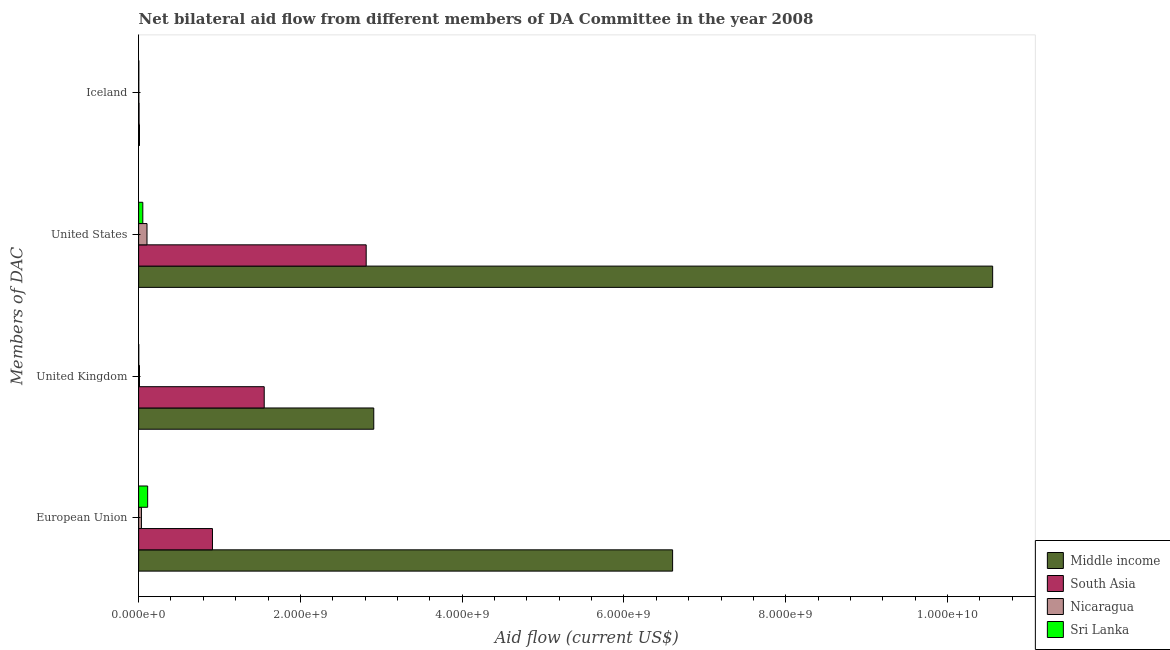Are the number of bars on each tick of the Y-axis equal?
Your answer should be very brief. Yes. What is the amount of aid given by iceland in South Asia?
Offer a very short reply. 5.30e+06. Across all countries, what is the maximum amount of aid given by eu?
Offer a terse response. 6.60e+09. Across all countries, what is the minimum amount of aid given by eu?
Provide a short and direct response. 3.48e+07. In which country was the amount of aid given by eu minimum?
Your answer should be very brief. Nicaragua. What is the total amount of aid given by iceland in the graph?
Your answer should be very brief. 2.06e+07. What is the difference between the amount of aid given by iceland in South Asia and that in Nicaragua?
Your answer should be very brief. 3.07e+06. What is the difference between the amount of aid given by uk in Middle income and the amount of aid given by eu in Sri Lanka?
Provide a short and direct response. 2.80e+09. What is the average amount of aid given by us per country?
Your response must be concise. 3.38e+09. What is the difference between the amount of aid given by iceland and amount of aid given by uk in Nicaragua?
Your answer should be compact. -8.43e+06. What is the ratio of the amount of aid given by iceland in South Asia to that in Middle income?
Your answer should be compact. 0.5. Is the amount of aid given by us in South Asia less than that in Nicaragua?
Keep it short and to the point. No. Is the difference between the amount of aid given by eu in South Asia and Middle income greater than the difference between the amount of aid given by iceland in South Asia and Middle income?
Give a very brief answer. No. What is the difference between the highest and the second highest amount of aid given by eu?
Offer a terse response. 5.69e+09. What is the difference between the highest and the lowest amount of aid given by eu?
Ensure brevity in your answer.  6.57e+09. In how many countries, is the amount of aid given by us greater than the average amount of aid given by us taken over all countries?
Offer a very short reply. 1. Is it the case that in every country, the sum of the amount of aid given by eu and amount of aid given by iceland is greater than the sum of amount of aid given by uk and amount of aid given by us?
Offer a terse response. Yes. What does the 4th bar from the top in Iceland represents?
Your answer should be compact. Middle income. What does the 3rd bar from the bottom in United Kingdom represents?
Keep it short and to the point. Nicaragua. Are all the bars in the graph horizontal?
Offer a terse response. Yes. What is the difference between two consecutive major ticks on the X-axis?
Ensure brevity in your answer.  2.00e+09. Does the graph contain any zero values?
Provide a succinct answer. No. How are the legend labels stacked?
Give a very brief answer. Vertical. What is the title of the graph?
Provide a succinct answer. Net bilateral aid flow from different members of DA Committee in the year 2008. What is the label or title of the Y-axis?
Your answer should be very brief. Members of DAC. What is the Aid flow (current US$) in Middle income in European Union?
Give a very brief answer. 6.60e+09. What is the Aid flow (current US$) of South Asia in European Union?
Provide a succinct answer. 9.13e+08. What is the Aid flow (current US$) of Nicaragua in European Union?
Your answer should be very brief. 3.48e+07. What is the Aid flow (current US$) of Sri Lanka in European Union?
Keep it short and to the point. 1.12e+08. What is the Aid flow (current US$) in Middle income in United Kingdom?
Offer a very short reply. 2.91e+09. What is the Aid flow (current US$) of South Asia in United Kingdom?
Give a very brief answer. 1.55e+09. What is the Aid flow (current US$) in Nicaragua in United Kingdom?
Your answer should be compact. 1.07e+07. What is the Aid flow (current US$) of Sri Lanka in United Kingdom?
Your response must be concise. 1.75e+06. What is the Aid flow (current US$) in Middle income in United States?
Offer a terse response. 1.06e+1. What is the Aid flow (current US$) of South Asia in United States?
Provide a succinct answer. 2.81e+09. What is the Aid flow (current US$) in Nicaragua in United States?
Your response must be concise. 1.04e+08. What is the Aid flow (current US$) of Sri Lanka in United States?
Your response must be concise. 5.18e+07. What is the Aid flow (current US$) in Middle income in Iceland?
Ensure brevity in your answer.  1.06e+07. What is the Aid flow (current US$) of South Asia in Iceland?
Your response must be concise. 5.30e+06. What is the Aid flow (current US$) of Nicaragua in Iceland?
Provide a succinct answer. 2.23e+06. What is the Aid flow (current US$) in Sri Lanka in Iceland?
Your answer should be very brief. 2.39e+06. Across all Members of DAC, what is the maximum Aid flow (current US$) in Middle income?
Ensure brevity in your answer.  1.06e+1. Across all Members of DAC, what is the maximum Aid flow (current US$) in South Asia?
Make the answer very short. 2.81e+09. Across all Members of DAC, what is the maximum Aid flow (current US$) of Nicaragua?
Offer a terse response. 1.04e+08. Across all Members of DAC, what is the maximum Aid flow (current US$) in Sri Lanka?
Offer a very short reply. 1.12e+08. Across all Members of DAC, what is the minimum Aid flow (current US$) of Middle income?
Keep it short and to the point. 1.06e+07. Across all Members of DAC, what is the minimum Aid flow (current US$) of South Asia?
Your answer should be compact. 5.30e+06. Across all Members of DAC, what is the minimum Aid flow (current US$) of Nicaragua?
Keep it short and to the point. 2.23e+06. Across all Members of DAC, what is the minimum Aid flow (current US$) in Sri Lanka?
Give a very brief answer. 1.75e+06. What is the total Aid flow (current US$) of Middle income in the graph?
Give a very brief answer. 2.01e+1. What is the total Aid flow (current US$) in South Asia in the graph?
Your answer should be very brief. 5.28e+09. What is the total Aid flow (current US$) in Nicaragua in the graph?
Provide a short and direct response. 1.51e+08. What is the total Aid flow (current US$) of Sri Lanka in the graph?
Ensure brevity in your answer.  1.68e+08. What is the difference between the Aid flow (current US$) of Middle income in European Union and that in United Kingdom?
Ensure brevity in your answer.  3.69e+09. What is the difference between the Aid flow (current US$) in South Asia in European Union and that in United Kingdom?
Keep it short and to the point. -6.40e+08. What is the difference between the Aid flow (current US$) in Nicaragua in European Union and that in United Kingdom?
Make the answer very short. 2.41e+07. What is the difference between the Aid flow (current US$) in Sri Lanka in European Union and that in United Kingdom?
Offer a very short reply. 1.10e+08. What is the difference between the Aid flow (current US$) in Middle income in European Union and that in United States?
Provide a short and direct response. -3.96e+09. What is the difference between the Aid flow (current US$) of South Asia in European Union and that in United States?
Your answer should be very brief. -1.90e+09. What is the difference between the Aid flow (current US$) of Nicaragua in European Union and that in United States?
Your response must be concise. -6.87e+07. What is the difference between the Aid flow (current US$) in Sri Lanka in European Union and that in United States?
Offer a very short reply. 5.98e+07. What is the difference between the Aid flow (current US$) in Middle income in European Union and that in Iceland?
Ensure brevity in your answer.  6.59e+09. What is the difference between the Aid flow (current US$) of South Asia in European Union and that in Iceland?
Your answer should be very brief. 9.08e+08. What is the difference between the Aid flow (current US$) of Nicaragua in European Union and that in Iceland?
Ensure brevity in your answer.  3.26e+07. What is the difference between the Aid flow (current US$) of Sri Lanka in European Union and that in Iceland?
Ensure brevity in your answer.  1.09e+08. What is the difference between the Aid flow (current US$) in Middle income in United Kingdom and that in United States?
Your answer should be compact. -7.65e+09. What is the difference between the Aid flow (current US$) in South Asia in United Kingdom and that in United States?
Offer a very short reply. -1.26e+09. What is the difference between the Aid flow (current US$) of Nicaragua in United Kingdom and that in United States?
Ensure brevity in your answer.  -9.29e+07. What is the difference between the Aid flow (current US$) of Sri Lanka in United Kingdom and that in United States?
Your answer should be very brief. -5.00e+07. What is the difference between the Aid flow (current US$) in Middle income in United Kingdom and that in Iceland?
Offer a very short reply. 2.90e+09. What is the difference between the Aid flow (current US$) of South Asia in United Kingdom and that in Iceland?
Ensure brevity in your answer.  1.55e+09. What is the difference between the Aid flow (current US$) in Nicaragua in United Kingdom and that in Iceland?
Provide a succinct answer. 8.43e+06. What is the difference between the Aid flow (current US$) of Sri Lanka in United Kingdom and that in Iceland?
Your answer should be compact. -6.40e+05. What is the difference between the Aid flow (current US$) in Middle income in United States and that in Iceland?
Your answer should be very brief. 1.05e+1. What is the difference between the Aid flow (current US$) in South Asia in United States and that in Iceland?
Make the answer very short. 2.81e+09. What is the difference between the Aid flow (current US$) in Nicaragua in United States and that in Iceland?
Offer a very short reply. 1.01e+08. What is the difference between the Aid flow (current US$) of Sri Lanka in United States and that in Iceland?
Your answer should be very brief. 4.94e+07. What is the difference between the Aid flow (current US$) of Middle income in European Union and the Aid flow (current US$) of South Asia in United Kingdom?
Provide a succinct answer. 5.05e+09. What is the difference between the Aid flow (current US$) of Middle income in European Union and the Aid flow (current US$) of Nicaragua in United Kingdom?
Your answer should be compact. 6.59e+09. What is the difference between the Aid flow (current US$) of Middle income in European Union and the Aid flow (current US$) of Sri Lanka in United Kingdom?
Your response must be concise. 6.60e+09. What is the difference between the Aid flow (current US$) in South Asia in European Union and the Aid flow (current US$) in Nicaragua in United Kingdom?
Provide a short and direct response. 9.02e+08. What is the difference between the Aid flow (current US$) of South Asia in European Union and the Aid flow (current US$) of Sri Lanka in United Kingdom?
Keep it short and to the point. 9.11e+08. What is the difference between the Aid flow (current US$) in Nicaragua in European Union and the Aid flow (current US$) in Sri Lanka in United Kingdom?
Your answer should be very brief. 3.30e+07. What is the difference between the Aid flow (current US$) in Middle income in European Union and the Aid flow (current US$) in South Asia in United States?
Provide a short and direct response. 3.79e+09. What is the difference between the Aid flow (current US$) of Middle income in European Union and the Aid flow (current US$) of Nicaragua in United States?
Your answer should be compact. 6.50e+09. What is the difference between the Aid flow (current US$) in Middle income in European Union and the Aid flow (current US$) in Sri Lanka in United States?
Provide a succinct answer. 6.55e+09. What is the difference between the Aid flow (current US$) of South Asia in European Union and the Aid flow (current US$) of Nicaragua in United States?
Offer a very short reply. 8.09e+08. What is the difference between the Aid flow (current US$) in South Asia in European Union and the Aid flow (current US$) in Sri Lanka in United States?
Offer a very short reply. 8.61e+08. What is the difference between the Aid flow (current US$) in Nicaragua in European Union and the Aid flow (current US$) in Sri Lanka in United States?
Keep it short and to the point. -1.70e+07. What is the difference between the Aid flow (current US$) in Middle income in European Union and the Aid flow (current US$) in South Asia in Iceland?
Offer a very short reply. 6.60e+09. What is the difference between the Aid flow (current US$) of Middle income in European Union and the Aid flow (current US$) of Nicaragua in Iceland?
Provide a succinct answer. 6.60e+09. What is the difference between the Aid flow (current US$) of Middle income in European Union and the Aid flow (current US$) of Sri Lanka in Iceland?
Provide a succinct answer. 6.60e+09. What is the difference between the Aid flow (current US$) of South Asia in European Union and the Aid flow (current US$) of Nicaragua in Iceland?
Provide a succinct answer. 9.11e+08. What is the difference between the Aid flow (current US$) of South Asia in European Union and the Aid flow (current US$) of Sri Lanka in Iceland?
Make the answer very short. 9.10e+08. What is the difference between the Aid flow (current US$) in Nicaragua in European Union and the Aid flow (current US$) in Sri Lanka in Iceland?
Ensure brevity in your answer.  3.24e+07. What is the difference between the Aid flow (current US$) in Middle income in United Kingdom and the Aid flow (current US$) in South Asia in United States?
Ensure brevity in your answer.  9.37e+07. What is the difference between the Aid flow (current US$) in Middle income in United Kingdom and the Aid flow (current US$) in Nicaragua in United States?
Your answer should be very brief. 2.80e+09. What is the difference between the Aid flow (current US$) of Middle income in United Kingdom and the Aid flow (current US$) of Sri Lanka in United States?
Ensure brevity in your answer.  2.86e+09. What is the difference between the Aid flow (current US$) of South Asia in United Kingdom and the Aid flow (current US$) of Nicaragua in United States?
Keep it short and to the point. 1.45e+09. What is the difference between the Aid flow (current US$) in South Asia in United Kingdom and the Aid flow (current US$) in Sri Lanka in United States?
Provide a short and direct response. 1.50e+09. What is the difference between the Aid flow (current US$) of Nicaragua in United Kingdom and the Aid flow (current US$) of Sri Lanka in United States?
Your answer should be compact. -4.11e+07. What is the difference between the Aid flow (current US$) in Middle income in United Kingdom and the Aid flow (current US$) in South Asia in Iceland?
Keep it short and to the point. 2.90e+09. What is the difference between the Aid flow (current US$) of Middle income in United Kingdom and the Aid flow (current US$) of Nicaragua in Iceland?
Offer a terse response. 2.90e+09. What is the difference between the Aid flow (current US$) of Middle income in United Kingdom and the Aid flow (current US$) of Sri Lanka in Iceland?
Make the answer very short. 2.90e+09. What is the difference between the Aid flow (current US$) in South Asia in United Kingdom and the Aid flow (current US$) in Nicaragua in Iceland?
Ensure brevity in your answer.  1.55e+09. What is the difference between the Aid flow (current US$) of South Asia in United Kingdom and the Aid flow (current US$) of Sri Lanka in Iceland?
Give a very brief answer. 1.55e+09. What is the difference between the Aid flow (current US$) in Nicaragua in United Kingdom and the Aid flow (current US$) in Sri Lanka in Iceland?
Make the answer very short. 8.27e+06. What is the difference between the Aid flow (current US$) in Middle income in United States and the Aid flow (current US$) in South Asia in Iceland?
Offer a very short reply. 1.06e+1. What is the difference between the Aid flow (current US$) in Middle income in United States and the Aid flow (current US$) in Nicaragua in Iceland?
Your answer should be compact. 1.06e+1. What is the difference between the Aid flow (current US$) of Middle income in United States and the Aid flow (current US$) of Sri Lanka in Iceland?
Offer a very short reply. 1.06e+1. What is the difference between the Aid flow (current US$) in South Asia in United States and the Aid flow (current US$) in Nicaragua in Iceland?
Give a very brief answer. 2.81e+09. What is the difference between the Aid flow (current US$) of South Asia in United States and the Aid flow (current US$) of Sri Lanka in Iceland?
Offer a very short reply. 2.81e+09. What is the difference between the Aid flow (current US$) of Nicaragua in United States and the Aid flow (current US$) of Sri Lanka in Iceland?
Your answer should be very brief. 1.01e+08. What is the average Aid flow (current US$) of Middle income per Members of DAC?
Your response must be concise. 5.02e+09. What is the average Aid flow (current US$) in South Asia per Members of DAC?
Provide a succinct answer. 1.32e+09. What is the average Aid flow (current US$) in Nicaragua per Members of DAC?
Offer a very short reply. 3.78e+07. What is the average Aid flow (current US$) in Sri Lanka per Members of DAC?
Your response must be concise. 4.19e+07. What is the difference between the Aid flow (current US$) of Middle income and Aid flow (current US$) of South Asia in European Union?
Offer a very short reply. 5.69e+09. What is the difference between the Aid flow (current US$) of Middle income and Aid flow (current US$) of Nicaragua in European Union?
Your answer should be very brief. 6.57e+09. What is the difference between the Aid flow (current US$) of Middle income and Aid flow (current US$) of Sri Lanka in European Union?
Keep it short and to the point. 6.49e+09. What is the difference between the Aid flow (current US$) in South Asia and Aid flow (current US$) in Nicaragua in European Union?
Offer a terse response. 8.78e+08. What is the difference between the Aid flow (current US$) of South Asia and Aid flow (current US$) of Sri Lanka in European Union?
Your response must be concise. 8.01e+08. What is the difference between the Aid flow (current US$) in Nicaragua and Aid flow (current US$) in Sri Lanka in European Union?
Keep it short and to the point. -7.68e+07. What is the difference between the Aid flow (current US$) of Middle income and Aid flow (current US$) of South Asia in United Kingdom?
Offer a terse response. 1.35e+09. What is the difference between the Aid flow (current US$) of Middle income and Aid flow (current US$) of Nicaragua in United Kingdom?
Offer a terse response. 2.90e+09. What is the difference between the Aid flow (current US$) in Middle income and Aid flow (current US$) in Sri Lanka in United Kingdom?
Offer a terse response. 2.91e+09. What is the difference between the Aid flow (current US$) of South Asia and Aid flow (current US$) of Nicaragua in United Kingdom?
Your answer should be compact. 1.54e+09. What is the difference between the Aid flow (current US$) in South Asia and Aid flow (current US$) in Sri Lanka in United Kingdom?
Give a very brief answer. 1.55e+09. What is the difference between the Aid flow (current US$) in Nicaragua and Aid flow (current US$) in Sri Lanka in United Kingdom?
Your answer should be very brief. 8.91e+06. What is the difference between the Aid flow (current US$) in Middle income and Aid flow (current US$) in South Asia in United States?
Offer a very short reply. 7.74e+09. What is the difference between the Aid flow (current US$) of Middle income and Aid flow (current US$) of Nicaragua in United States?
Make the answer very short. 1.05e+1. What is the difference between the Aid flow (current US$) in Middle income and Aid flow (current US$) in Sri Lanka in United States?
Give a very brief answer. 1.05e+1. What is the difference between the Aid flow (current US$) of South Asia and Aid flow (current US$) of Nicaragua in United States?
Offer a very short reply. 2.71e+09. What is the difference between the Aid flow (current US$) in South Asia and Aid flow (current US$) in Sri Lanka in United States?
Ensure brevity in your answer.  2.76e+09. What is the difference between the Aid flow (current US$) of Nicaragua and Aid flow (current US$) of Sri Lanka in United States?
Your response must be concise. 5.17e+07. What is the difference between the Aid flow (current US$) of Middle income and Aid flow (current US$) of South Asia in Iceland?
Your answer should be very brief. 5.33e+06. What is the difference between the Aid flow (current US$) in Middle income and Aid flow (current US$) in Nicaragua in Iceland?
Make the answer very short. 8.40e+06. What is the difference between the Aid flow (current US$) in Middle income and Aid flow (current US$) in Sri Lanka in Iceland?
Provide a succinct answer. 8.24e+06. What is the difference between the Aid flow (current US$) of South Asia and Aid flow (current US$) of Nicaragua in Iceland?
Give a very brief answer. 3.07e+06. What is the difference between the Aid flow (current US$) in South Asia and Aid flow (current US$) in Sri Lanka in Iceland?
Provide a succinct answer. 2.91e+06. What is the difference between the Aid flow (current US$) of Nicaragua and Aid flow (current US$) of Sri Lanka in Iceland?
Provide a short and direct response. -1.60e+05. What is the ratio of the Aid flow (current US$) of Middle income in European Union to that in United Kingdom?
Offer a very short reply. 2.27. What is the ratio of the Aid flow (current US$) in South Asia in European Union to that in United Kingdom?
Your answer should be very brief. 0.59. What is the ratio of the Aid flow (current US$) in Nicaragua in European Union to that in United Kingdom?
Ensure brevity in your answer.  3.26. What is the ratio of the Aid flow (current US$) of Sri Lanka in European Union to that in United Kingdom?
Your response must be concise. 63.77. What is the ratio of the Aid flow (current US$) of Middle income in European Union to that in United States?
Provide a succinct answer. 0.63. What is the ratio of the Aid flow (current US$) in South Asia in European Union to that in United States?
Provide a short and direct response. 0.32. What is the ratio of the Aid flow (current US$) in Nicaragua in European Union to that in United States?
Offer a very short reply. 0.34. What is the ratio of the Aid flow (current US$) in Sri Lanka in European Union to that in United States?
Your answer should be very brief. 2.15. What is the ratio of the Aid flow (current US$) in Middle income in European Union to that in Iceland?
Your response must be concise. 620.99. What is the ratio of the Aid flow (current US$) in South Asia in European Union to that in Iceland?
Make the answer very short. 172.23. What is the ratio of the Aid flow (current US$) of Nicaragua in European Union to that in Iceland?
Your response must be concise. 15.6. What is the ratio of the Aid flow (current US$) of Sri Lanka in European Union to that in Iceland?
Offer a very short reply. 46.69. What is the ratio of the Aid flow (current US$) of Middle income in United Kingdom to that in United States?
Give a very brief answer. 0.28. What is the ratio of the Aid flow (current US$) of South Asia in United Kingdom to that in United States?
Your answer should be compact. 0.55. What is the ratio of the Aid flow (current US$) in Nicaragua in United Kingdom to that in United States?
Make the answer very short. 0.1. What is the ratio of the Aid flow (current US$) in Sri Lanka in United Kingdom to that in United States?
Offer a very short reply. 0.03. What is the ratio of the Aid flow (current US$) of Middle income in United Kingdom to that in Iceland?
Provide a succinct answer. 273.45. What is the ratio of the Aid flow (current US$) of South Asia in United Kingdom to that in Iceland?
Provide a succinct answer. 292.95. What is the ratio of the Aid flow (current US$) of Nicaragua in United Kingdom to that in Iceland?
Keep it short and to the point. 4.78. What is the ratio of the Aid flow (current US$) of Sri Lanka in United Kingdom to that in Iceland?
Ensure brevity in your answer.  0.73. What is the ratio of the Aid flow (current US$) in Middle income in United States to that in Iceland?
Offer a very short reply. 993.2. What is the ratio of the Aid flow (current US$) of South Asia in United States to that in Iceland?
Provide a succinct answer. 530.78. What is the ratio of the Aid flow (current US$) in Nicaragua in United States to that in Iceland?
Ensure brevity in your answer.  46.43. What is the ratio of the Aid flow (current US$) in Sri Lanka in United States to that in Iceland?
Your response must be concise. 21.67. What is the difference between the highest and the second highest Aid flow (current US$) in Middle income?
Keep it short and to the point. 3.96e+09. What is the difference between the highest and the second highest Aid flow (current US$) of South Asia?
Provide a succinct answer. 1.26e+09. What is the difference between the highest and the second highest Aid flow (current US$) in Nicaragua?
Keep it short and to the point. 6.87e+07. What is the difference between the highest and the second highest Aid flow (current US$) of Sri Lanka?
Provide a succinct answer. 5.98e+07. What is the difference between the highest and the lowest Aid flow (current US$) in Middle income?
Provide a succinct answer. 1.05e+1. What is the difference between the highest and the lowest Aid flow (current US$) of South Asia?
Ensure brevity in your answer.  2.81e+09. What is the difference between the highest and the lowest Aid flow (current US$) of Nicaragua?
Make the answer very short. 1.01e+08. What is the difference between the highest and the lowest Aid flow (current US$) in Sri Lanka?
Offer a terse response. 1.10e+08. 